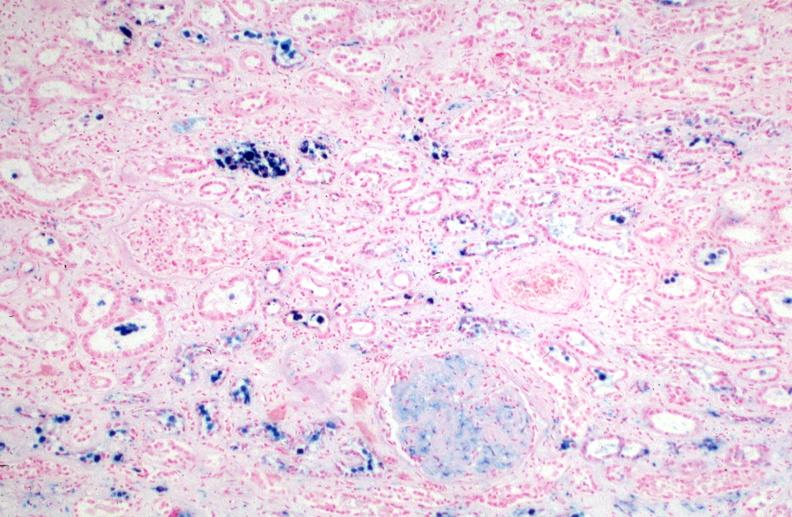s hemosiderosis caused by numerous blood transfusions.prusian blue?
Answer the question using a single word or phrase. Yes 